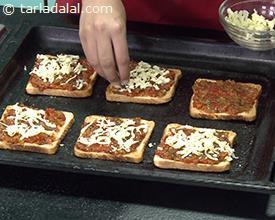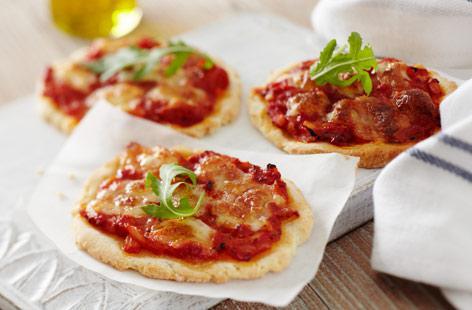The first image is the image on the left, the second image is the image on the right. Examine the images to the left and right. Is the description "In one image, four pieces of french bread pizza are covered with cheese, while a second image shows pizza made with slices of bread used for the crust." accurate? Answer yes or no. No. The first image is the image on the left, the second image is the image on the right. For the images shown, is this caption "One image shows four rectangles covered in red sauce, melted cheese, and green herbs on a wooden board, and the other image includes a topped slice of bread on a white plate." true? Answer yes or no. No. 